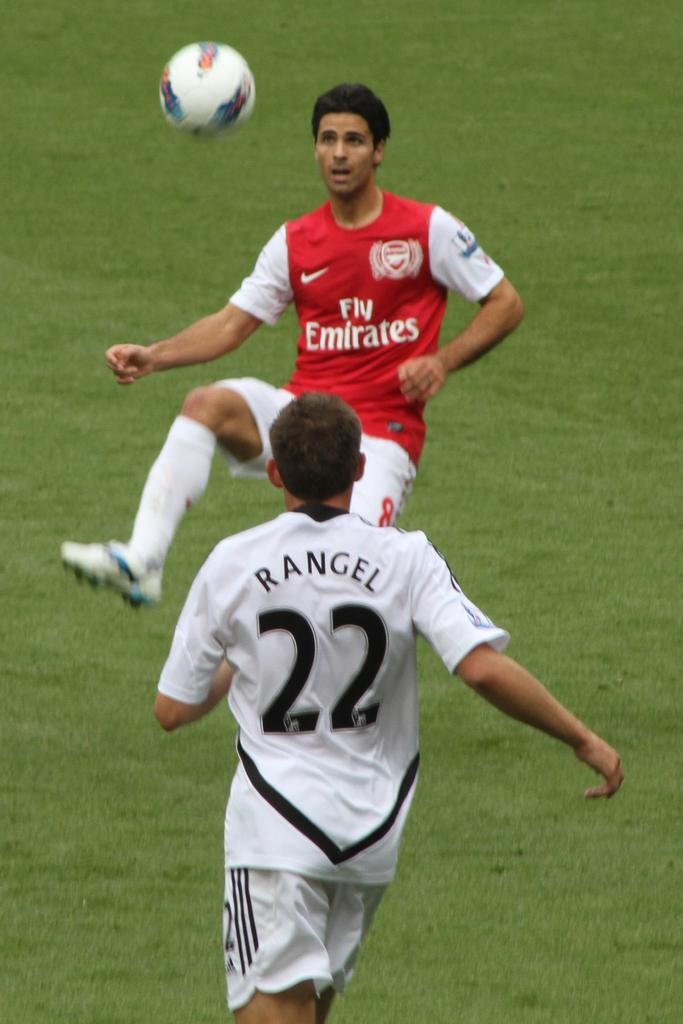<image>
Summarize the visual content of the image. 2 soccer players on a field with the one named RANGEL wearing the number 22 